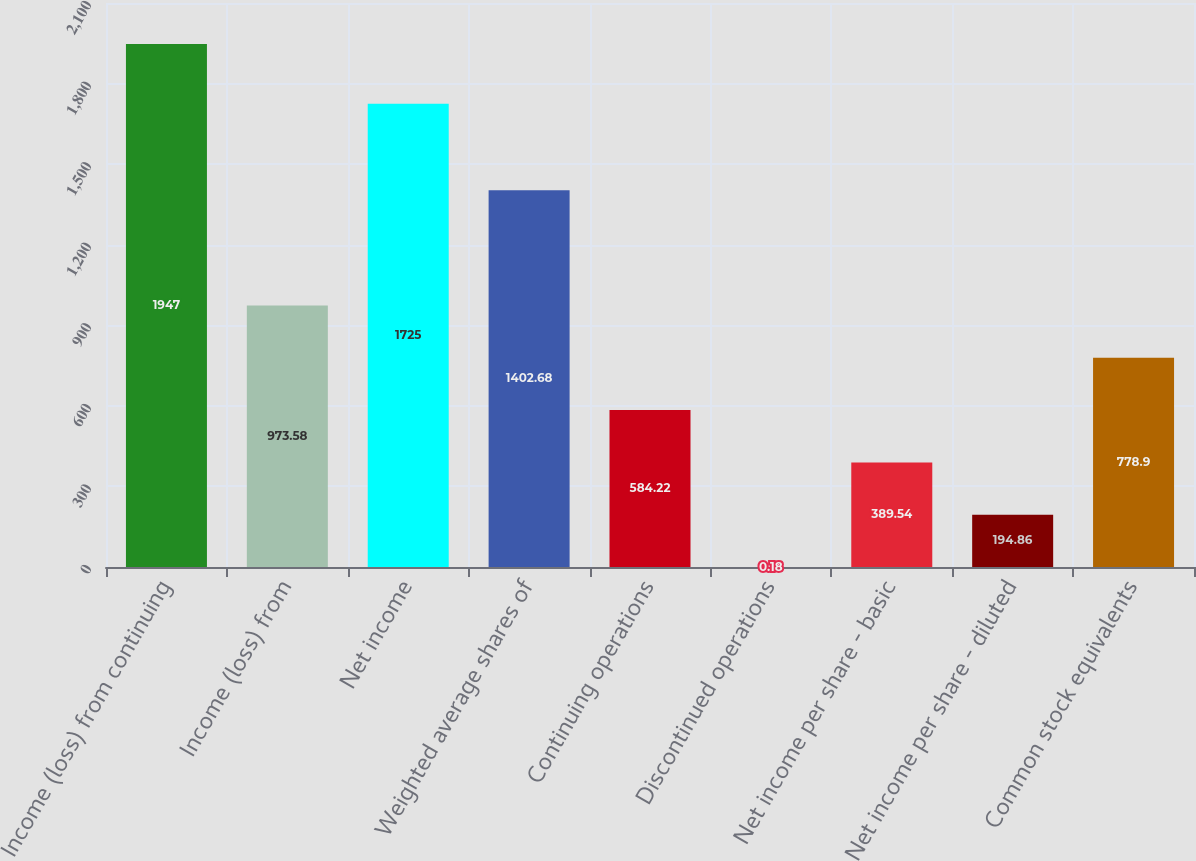Convert chart to OTSL. <chart><loc_0><loc_0><loc_500><loc_500><bar_chart><fcel>Income (loss) from continuing<fcel>Income (loss) from<fcel>Net income<fcel>Weighted average shares of<fcel>Continuing operations<fcel>Discontinued operations<fcel>Net income per share - basic<fcel>Net income per share - diluted<fcel>Common stock equivalents<nl><fcel>1947<fcel>973.58<fcel>1725<fcel>1402.68<fcel>584.22<fcel>0.18<fcel>389.54<fcel>194.86<fcel>778.9<nl></chart> 